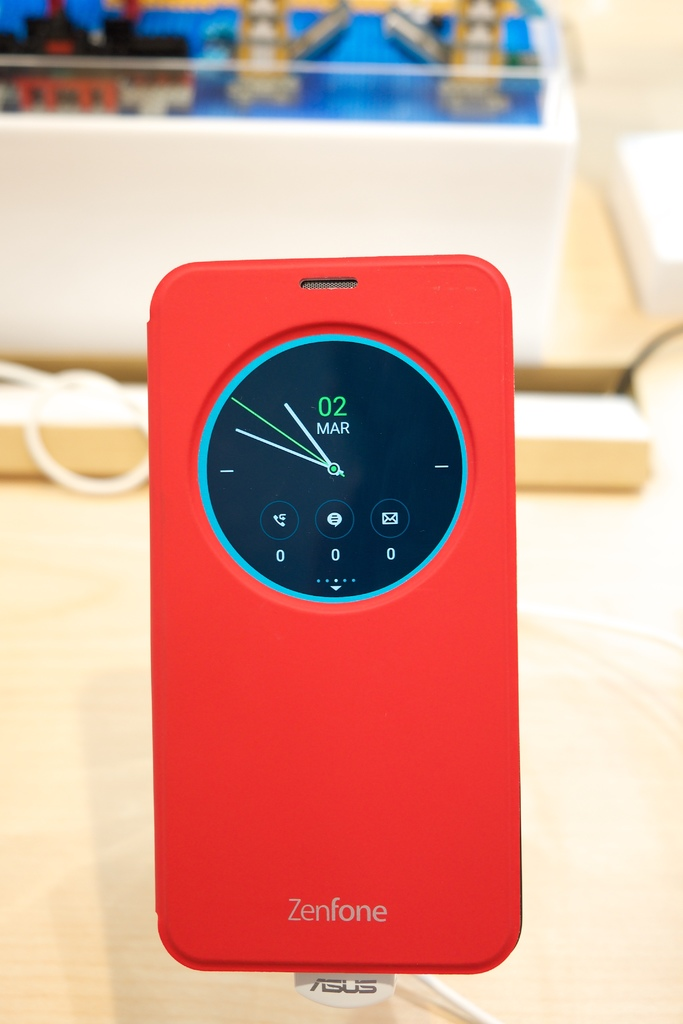Could you suggest some settings or scenarios where this type of phone case would be particularly useful? This type of phone case is particularly useful in scenarios where discreet yet constant updates are needed, like in meetings, during classes, or in environments where etiquette dictates minimal phone usage. It's also handy during travel or outdoor activities where quick glances for time and notifications are more practical. 